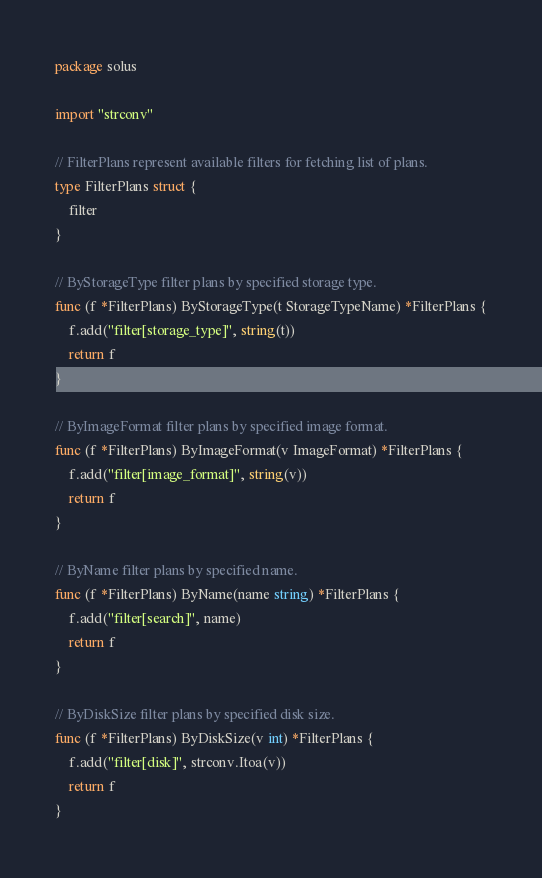Convert code to text. <code><loc_0><loc_0><loc_500><loc_500><_Go_>package solus

import "strconv"

// FilterPlans represent available filters for fetching list of plans.
type FilterPlans struct {
	filter
}

// ByStorageType filter plans by specified storage type.
func (f *FilterPlans) ByStorageType(t StorageTypeName) *FilterPlans {
	f.add("filter[storage_type]", string(t))
	return f
}

// ByImageFormat filter plans by specified image format.
func (f *FilterPlans) ByImageFormat(v ImageFormat) *FilterPlans {
	f.add("filter[image_format]", string(v))
	return f
}

// ByName filter plans by specified name.
func (f *FilterPlans) ByName(name string) *FilterPlans {
	f.add("filter[search]", name)
	return f
}

// ByDiskSize filter plans by specified disk size.
func (f *FilterPlans) ByDiskSize(v int) *FilterPlans {
	f.add("filter[disk]", strconv.Itoa(v))
	return f
}
</code> 